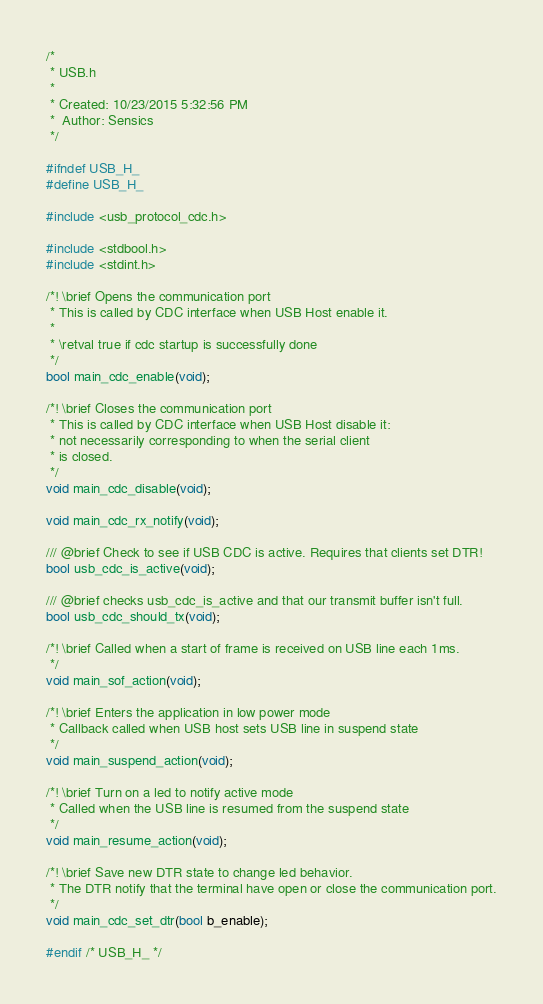<code> <loc_0><loc_0><loc_500><loc_500><_C_>/*
 * USB.h
 *
 * Created: 10/23/2015 5:32:56 PM
 *  Author: Sensics
 */

#ifndef USB_H_
#define USB_H_

#include <usb_protocol_cdc.h>

#include <stdbool.h>
#include <stdint.h>

/*! \brief Opens the communication port
 * This is called by CDC interface when USB Host enable it.
 *
 * \retval true if cdc startup is successfully done
 */
bool main_cdc_enable(void);

/*! \brief Closes the communication port
 * This is called by CDC interface when USB Host disable it:
 * not necessarily corresponding to when the serial client
 * is closed.
 */
void main_cdc_disable(void);

void main_cdc_rx_notify(void);

/// @brief Check to see if USB CDC is active. Requires that clients set DTR!
bool usb_cdc_is_active(void);

/// @brief checks usb_cdc_is_active and that our transmit buffer isn't full.
bool usb_cdc_should_tx(void);

/*! \brief Called when a start of frame is received on USB line each 1ms.
 */
void main_sof_action(void);

/*! \brief Enters the application in low power mode
 * Callback called when USB host sets USB line in suspend state
 */
void main_suspend_action(void);

/*! \brief Turn on a led to notify active mode
 * Called when the USB line is resumed from the suspend state
 */
void main_resume_action(void);

/*! \brief Save new DTR state to change led behavior.
 * The DTR notify that the terminal have open or close the communication port.
 */
void main_cdc_set_dtr(bool b_enable);

#endif /* USB_H_ */</code> 